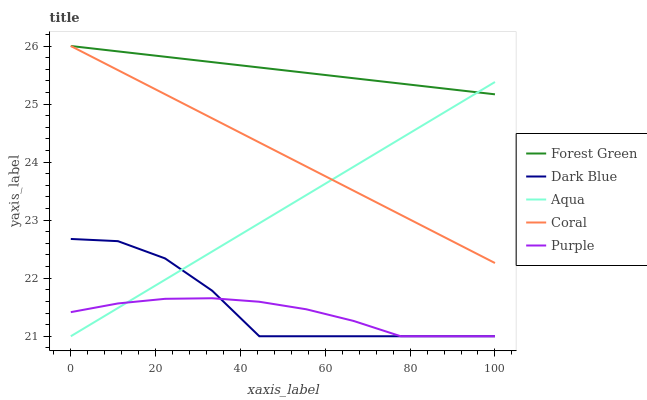Does Purple have the minimum area under the curve?
Answer yes or no. Yes. Does Forest Green have the maximum area under the curve?
Answer yes or no. Yes. Does Dark Blue have the minimum area under the curve?
Answer yes or no. No. Does Dark Blue have the maximum area under the curve?
Answer yes or no. No. Is Coral the smoothest?
Answer yes or no. Yes. Is Dark Blue the roughest?
Answer yes or no. Yes. Is Forest Green the smoothest?
Answer yes or no. No. Is Forest Green the roughest?
Answer yes or no. No. Does Purple have the lowest value?
Answer yes or no. Yes. Does Forest Green have the lowest value?
Answer yes or no. No. Does Coral have the highest value?
Answer yes or no. Yes. Does Dark Blue have the highest value?
Answer yes or no. No. Is Dark Blue less than Coral?
Answer yes or no. Yes. Is Forest Green greater than Purple?
Answer yes or no. Yes. Does Dark Blue intersect Aqua?
Answer yes or no. Yes. Is Dark Blue less than Aqua?
Answer yes or no. No. Is Dark Blue greater than Aqua?
Answer yes or no. No. Does Dark Blue intersect Coral?
Answer yes or no. No. 